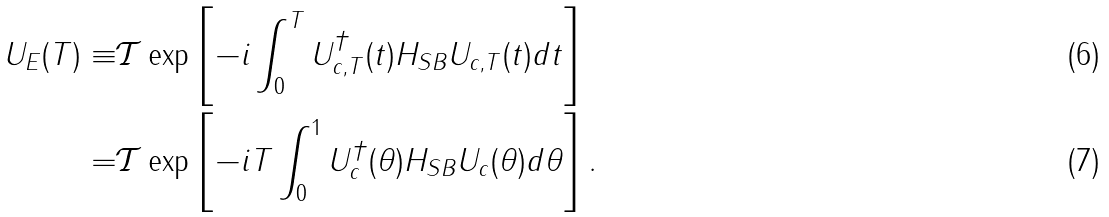<formula> <loc_0><loc_0><loc_500><loc_500>U _ { E } ( T ) \equiv & \mathcal { T } \exp \left [ - i \int _ { 0 } ^ { T } U _ { c , T } ^ { \dagger } ( t ) H _ { S B } U _ { c , T } ( t ) d t \right ] \\ = & \mathcal { T } \exp \left [ - i T \int _ { 0 } ^ { 1 } U _ { c } ^ { \dagger } ( \theta ) H _ { S B } U _ { c } ( \theta ) d \theta \right ] .</formula> 